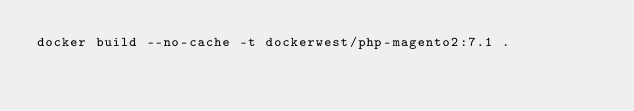Convert code to text. <code><loc_0><loc_0><loc_500><loc_500><_Bash_>docker build --no-cache -t dockerwest/php-magento2:7.1 .
</code> 